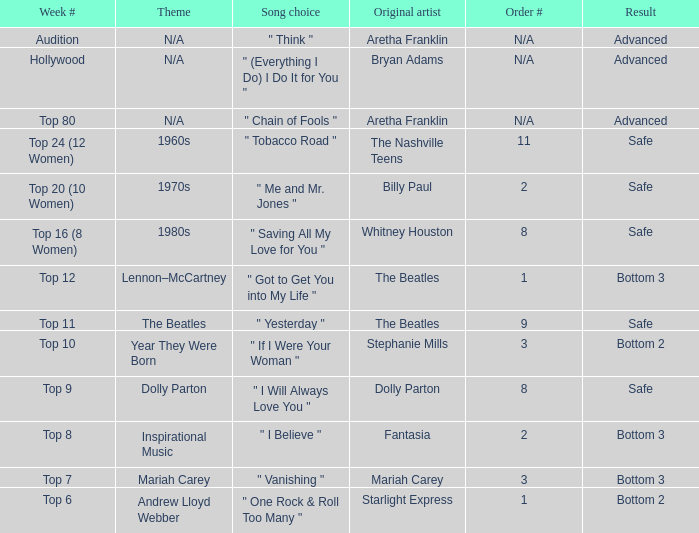Name the song choice when week number is hollywood " (Everything I Do) I Do It for You ". 